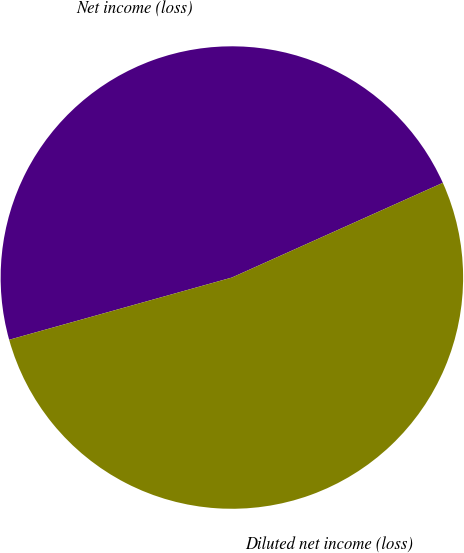<chart> <loc_0><loc_0><loc_500><loc_500><pie_chart><fcel>Net income (loss)<fcel>Diluted net income (loss)<nl><fcel>47.62%<fcel>52.38%<nl></chart> 